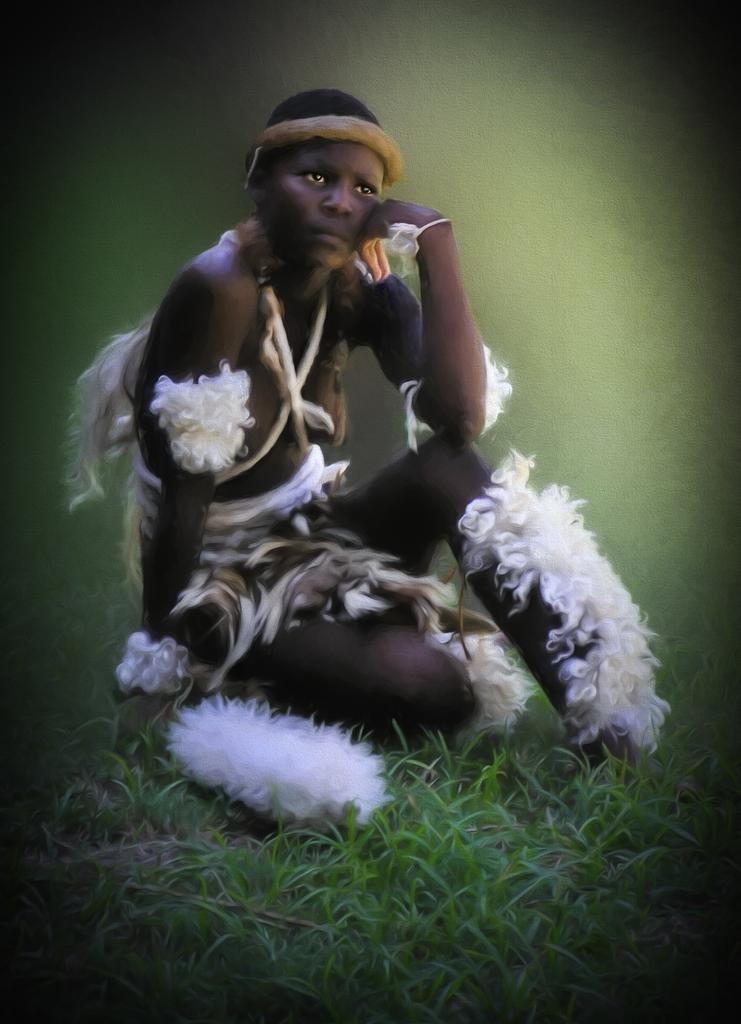Describe this image in one or two sentences. There is a woman sitting on grass and we can see feathers. In the background it is blur and green. 